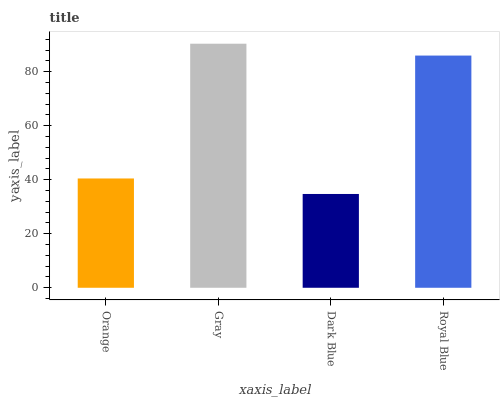Is Gray the minimum?
Answer yes or no. No. Is Dark Blue the maximum?
Answer yes or no. No. Is Gray greater than Dark Blue?
Answer yes or no. Yes. Is Dark Blue less than Gray?
Answer yes or no. Yes. Is Dark Blue greater than Gray?
Answer yes or no. No. Is Gray less than Dark Blue?
Answer yes or no. No. Is Royal Blue the high median?
Answer yes or no. Yes. Is Orange the low median?
Answer yes or no. Yes. Is Dark Blue the high median?
Answer yes or no. No. Is Royal Blue the low median?
Answer yes or no. No. 